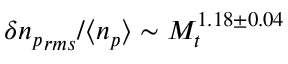<formula> <loc_0><loc_0><loc_500><loc_500>\delta { n _ { p } } _ { r m s } / \langle n _ { p } \rangle \sim M _ { t } ^ { 1 . 1 8 \pm 0 . 0 4 }</formula> 